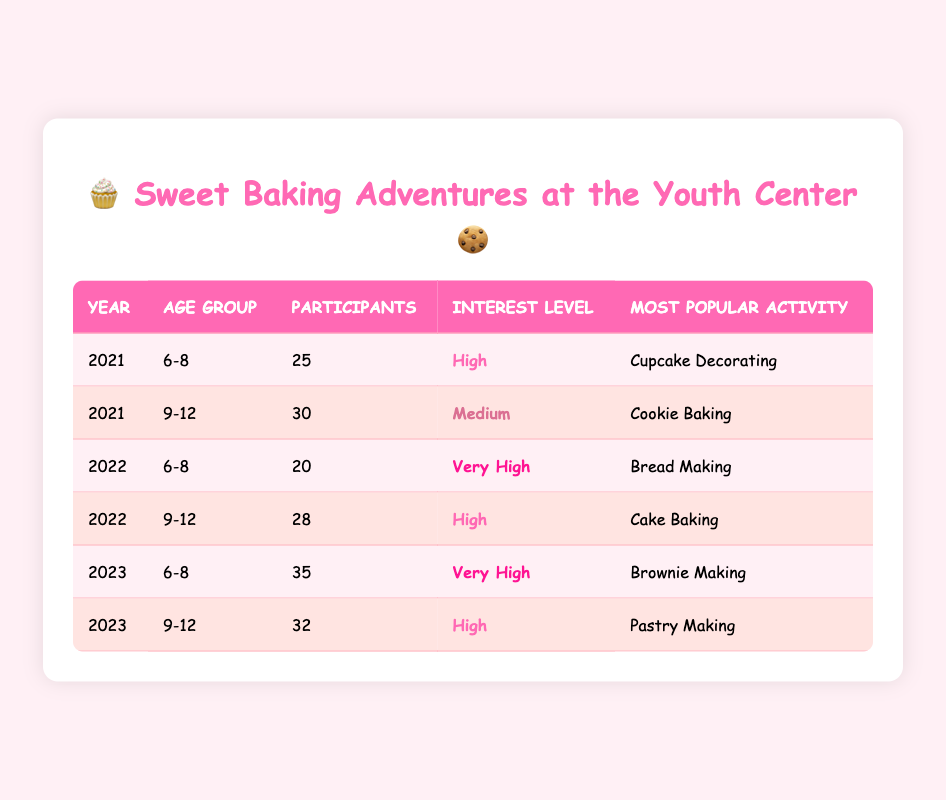What was the most popular baking activity for the age group 6-8 in 2023? According to the table, for the age group 6-8 in 2023, the most popular activity listed is Brownie Making.
Answer: Brownie Making How many participants were there in total for the 9-12 age group from 2021 to 2023? The number of participants for the 9-12 age group is 30 in 2021, 28 in 2022, and 32 in 2023. Adding these values together gives 30 + 28 + 32 = 90 participants in total.
Answer: 90 Did the interest level among the 6-8 age group increase from 2021 to 2023? In 2021, the interest level was High, in 2022 it was Very High, and in 2023 it remains Very High. Therefore, it can be concluded that the interest level increased from High in 2021 to Very High in both 2022 and 2023.
Answer: Yes What is the difference in the number of participants aged 9-12 between 2021 and 2022? The number of participants aged 9-12 was 30 in 2021 and 28 in 2022. To find the difference, subtract 28 from 30, resulting in 30 - 28 = 2.
Answer: 2 For which age group was the interest level highest in 2022? The table shows that for the 6-8 age group, the interest level was Very High in 2022, while the 9-12 age group had a High interest level. Therefore, the 6-8 age group had the highest interest level in 2022.
Answer: 6-8 age group What was the most popular baking activity in 2022 for the 9-12 age group? The table indicates that the most popular activity for the 9-12 age group in 2022 was Cake Baking.
Answer: Cake Baking 